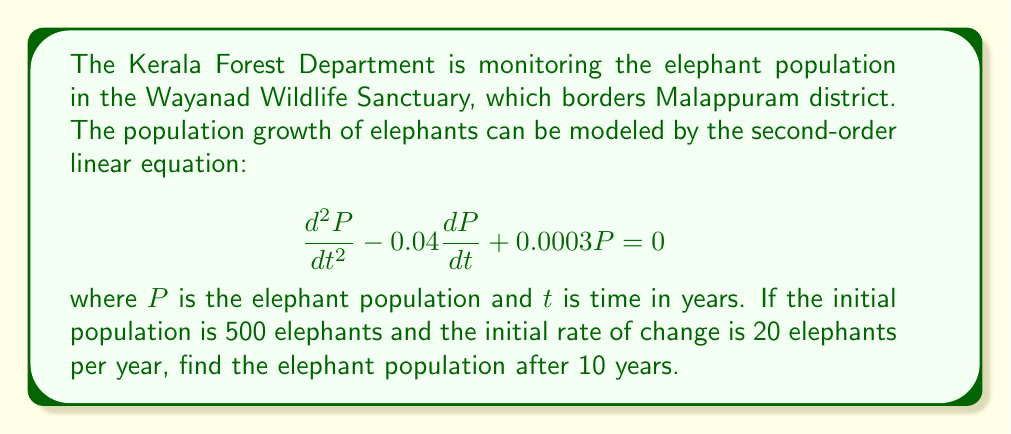Could you help me with this problem? To solve this second-order linear equation, we follow these steps:

1) The characteristic equation for this differential equation is:
   $$r^2 - 0.04r + 0.0003 = 0$$

2) Solving this quadratic equation:
   $$r = \frac{0.04 \pm \sqrt{0.04^2 - 4(1)(0.0003)}}{2(1)}$$
   $$r = \frac{0.04 \pm \sqrt{0.0016 - 0.0012}}{2}$$
   $$r = \frac{0.04 \pm \sqrt{0.0004}}{2}$$
   $$r = \frac{0.04 \pm 0.02}{2}$$

3) This gives us two roots:
   $$r_1 = 0.03 \text{ and } r_2 = 0.01$$

4) The general solution is therefore:
   $$P(t) = C_1e^{0.03t} + C_2e^{0.01t}$$

5) We need to find $C_1$ and $C_2$ using the initial conditions:
   At $t=0$, $P(0) = 500$ and $P'(0) = 20$

6) From $P(0) = 500$:
   $$500 = C_1 + C_2$$

7) From $P'(0) = 20$:
   $$P'(t) = 0.03C_1e^{0.03t} + 0.01C_2e^{0.01t}$$
   $$20 = 0.03C_1 + 0.01C_2$$

8) Solving these equations:
   $$C_1 = 250 \text{ and } C_2 = 250$$

9) Therefore, the particular solution is:
   $$P(t) = 250e^{0.03t} + 250e^{0.01t}$$

10) To find the population after 10 years, we substitute $t=10$:
    $$P(10) = 250e^{0.3} + 250e^{0.1}$$
    $$P(10) = 250(1.3498) + 250(1.1052)$$
    $$P(10) = 337.45 + 276.30$$
    $$P(10) = 613.75$$
Answer: The elephant population in Wayanad Wildlife Sanctuary after 10 years will be approximately 614 elephants. 